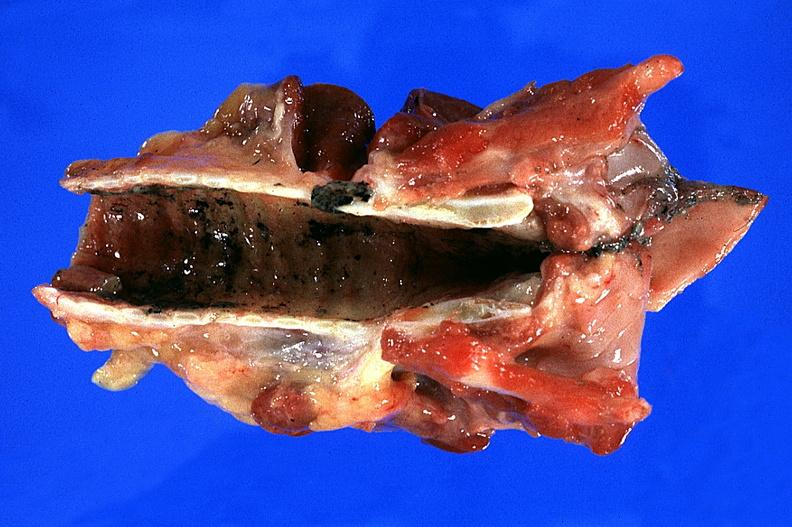does this image show trachea?
Answer the question using a single word or phrase. Yes 